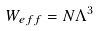<formula> <loc_0><loc_0><loc_500><loc_500>W _ { e f f } = N \Lambda ^ { 3 }</formula> 